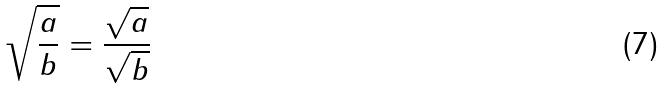Convert formula to latex. <formula><loc_0><loc_0><loc_500><loc_500>\sqrt { \frac { a } { b } } = \frac { \sqrt { a } } { \sqrt { b } }</formula> 